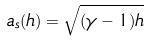<formula> <loc_0><loc_0><loc_500><loc_500>a _ { s } ( h ) = \sqrt { ( \gamma - 1 ) h }</formula> 